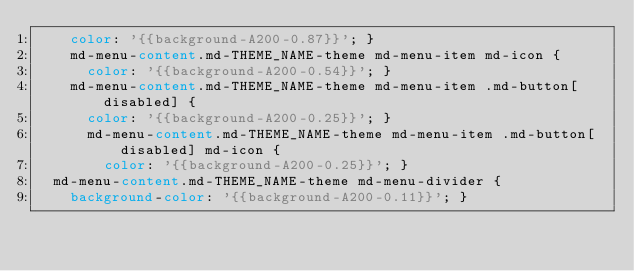<code> <loc_0><loc_0><loc_500><loc_500><_CSS_>    color: '{{background-A200-0.87}}'; }
    md-menu-content.md-THEME_NAME-theme md-menu-item md-icon {
      color: '{{background-A200-0.54}}'; }
    md-menu-content.md-THEME_NAME-theme md-menu-item .md-button[disabled] {
      color: '{{background-A200-0.25}}'; }
      md-menu-content.md-THEME_NAME-theme md-menu-item .md-button[disabled] md-icon {
        color: '{{background-A200-0.25}}'; }
  md-menu-content.md-THEME_NAME-theme md-menu-divider {
    background-color: '{{background-A200-0.11}}'; }
</code> 